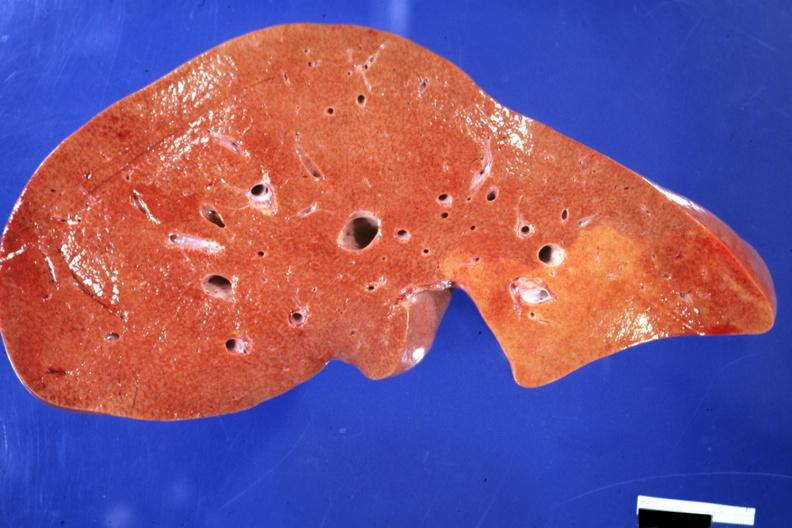what is present?
Answer the question using a single word or phrase. Hepatobiliary 